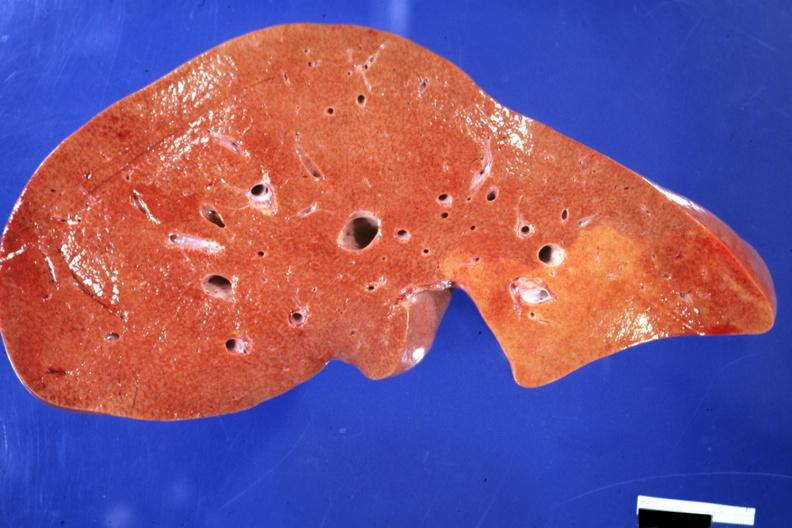what is present?
Answer the question using a single word or phrase. Hepatobiliary 